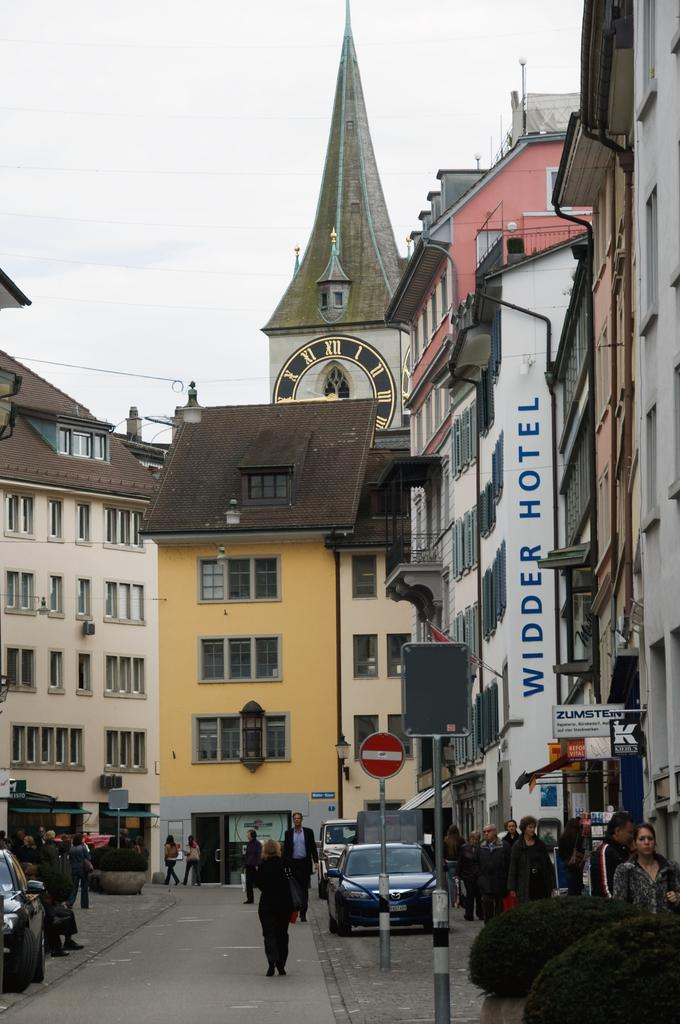What type of structures can be seen in the image? There are buildings in the image. What are the people on the footpath doing? There are people standing on the footpath. What can be seen on the road in the image? There are cars parked on the road. What type of coach is present in the image? There is no coach present in the image. What medical advice can be given by the doctor in the image? There is no doctor present in the image. 